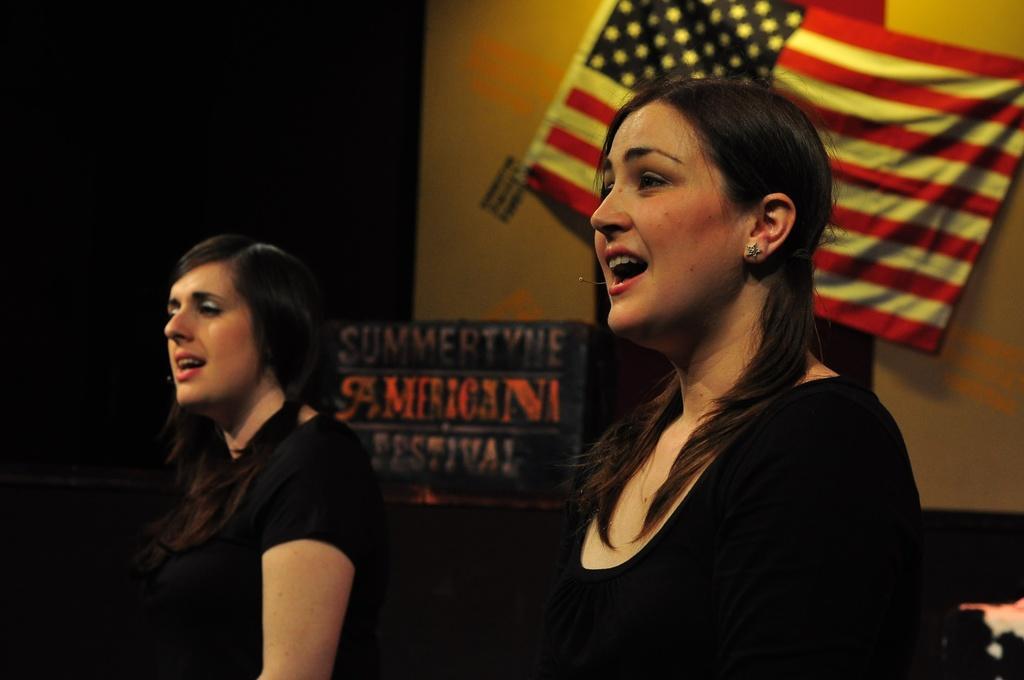How would you summarize this image in a sentence or two? In this image, we can see persons wearing clothes. There is a flag on the wall. There is a board in the middle of the image. 